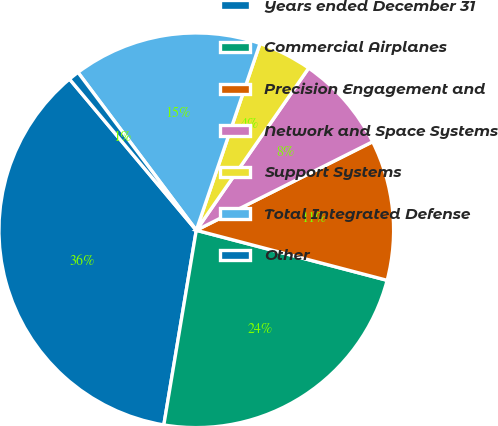<chart> <loc_0><loc_0><loc_500><loc_500><pie_chart><fcel>Years ended December 31<fcel>Commercial Airplanes<fcel>Precision Engagement and<fcel>Network and Space Systems<fcel>Support Systems<fcel>Total Integrated Defense<fcel>Other<nl><fcel>36.27%<fcel>23.55%<fcel>11.49%<fcel>7.95%<fcel>4.41%<fcel>15.47%<fcel>0.87%<nl></chart> 